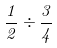<formula> <loc_0><loc_0><loc_500><loc_500>\frac { 1 } { 2 } \div \frac { 3 } { 4 }</formula> 